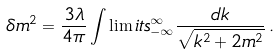<formula> <loc_0><loc_0><loc_500><loc_500>\delta m ^ { 2 } = \frac { 3 \lambda } { 4 \pi } \int \lim i t s _ { - \infty } ^ { \infty } \frac { d k } { \sqrt { k ^ { 2 } + 2 m ^ { 2 } } } \, .</formula> 